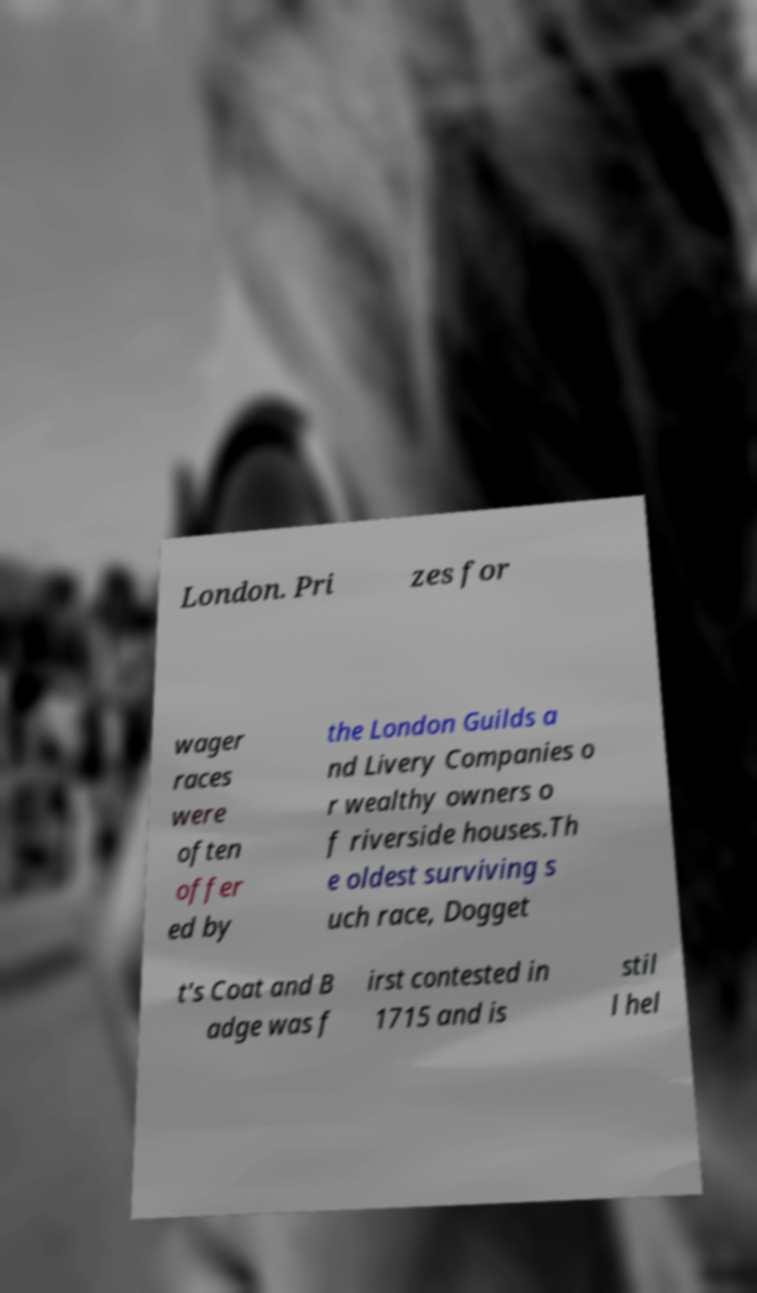There's text embedded in this image that I need extracted. Can you transcribe it verbatim? London. Pri zes for wager races were often offer ed by the London Guilds a nd Livery Companies o r wealthy owners o f riverside houses.Th e oldest surviving s uch race, Dogget t's Coat and B adge was f irst contested in 1715 and is stil l hel 